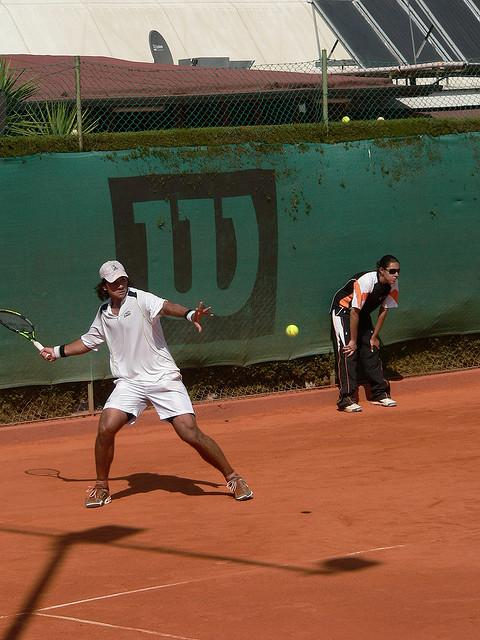What powers the facilities in this area?

Choices:
A) pedaling
B) hydronics
C) solar
D) steam solar 